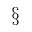<formula> <loc_0><loc_0><loc_500><loc_500>\S</formula> 